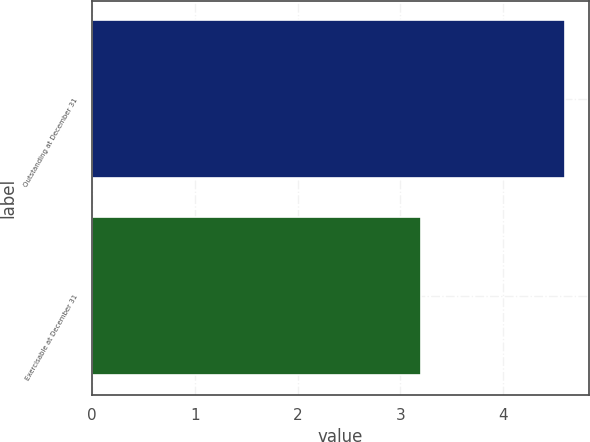<chart> <loc_0><loc_0><loc_500><loc_500><bar_chart><fcel>Outstanding at December 31<fcel>Exercisable at December 31<nl><fcel>4.6<fcel>3.2<nl></chart> 